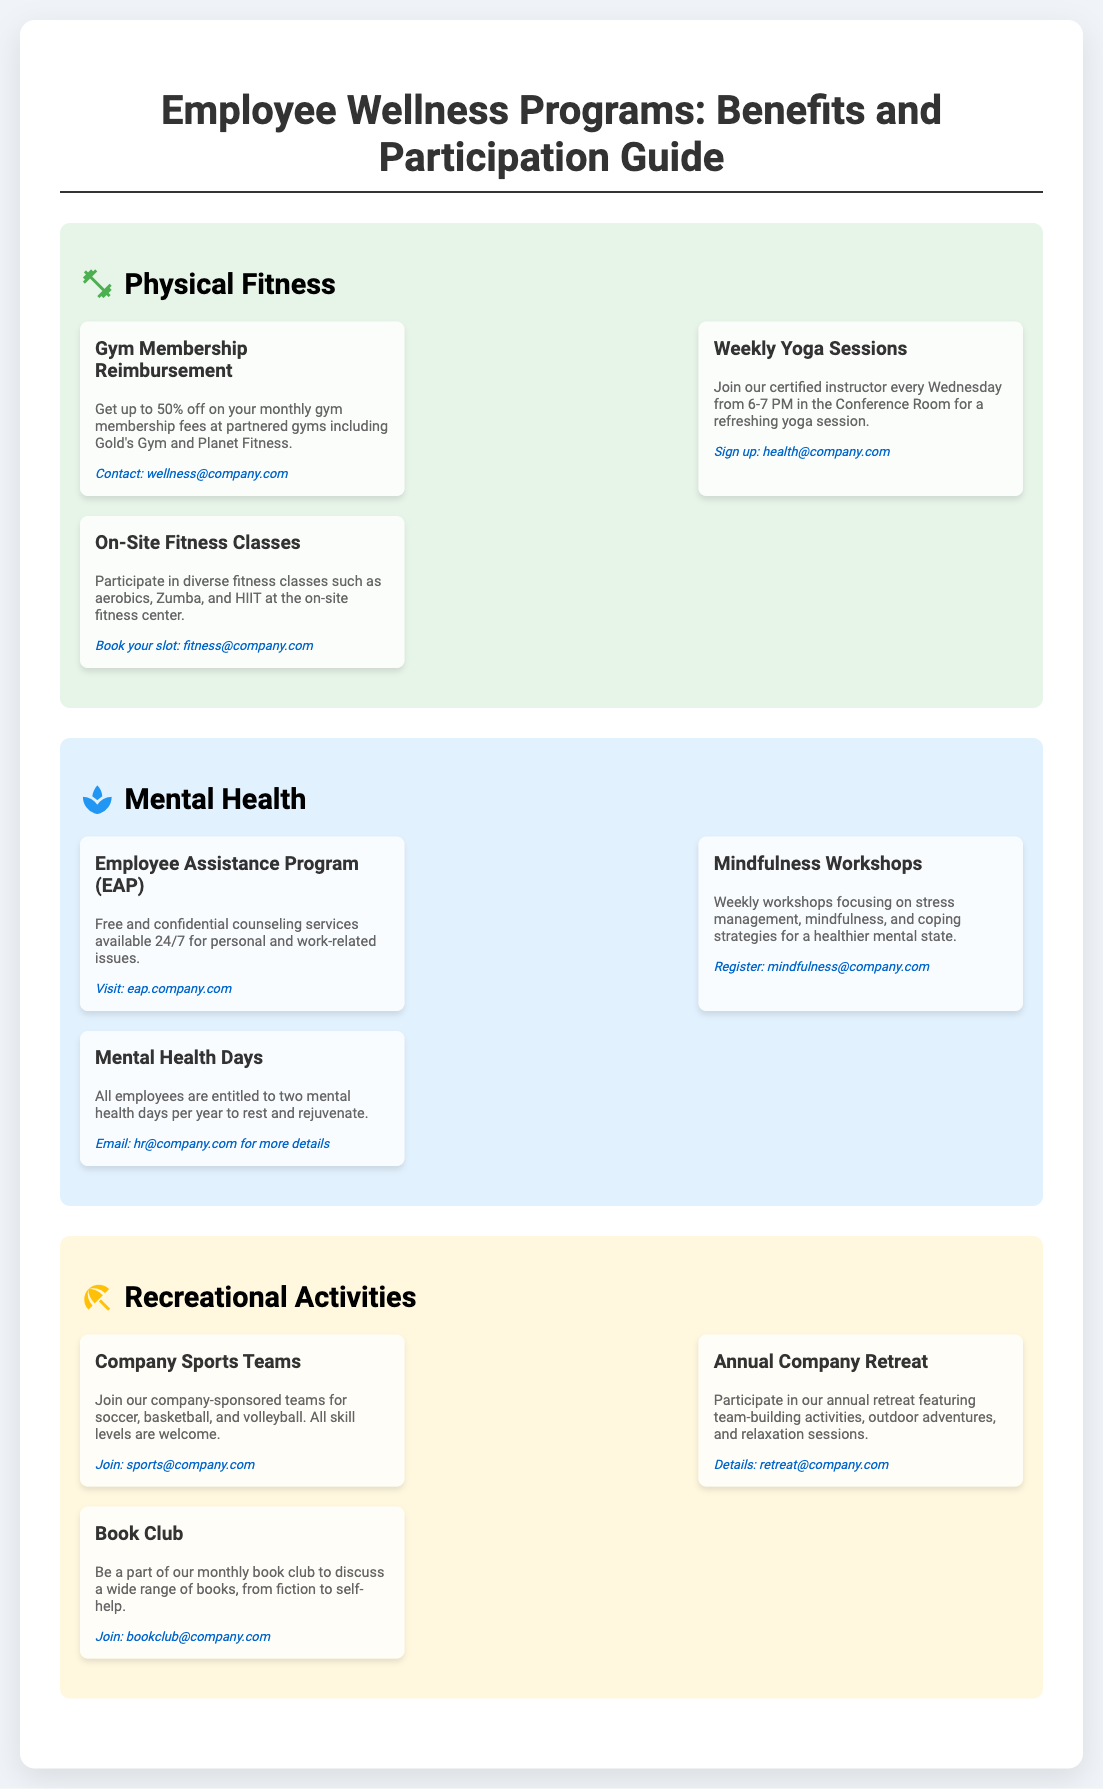What is the title of the poster? The title of the poster is prominently displayed at the top, outlining the focus on employee wellness programs.
Answer: Employee Wellness Programs: Benefits and Participation Guide How many mental health days are employees entitled to per year? The document specifically states the number of mental health days entitled to employees.
Answer: Two What is the contact email for gym membership reimbursement? The contact email related to gym membership reimbursement is provided in the details section of the program.
Answer: wellness@company.com When are the weekly yoga sessions held? The timing of the weekly yoga sessions is mentioned in the description for that activity.
Answer: Wednesdays from 6-7 PM What type of program offers free and confidential counseling services? The document categorizes services related to mental health under specific programs, including this particular program offering counseling.
Answer: Employee Assistance Program (EAP) Which recreational activity includes a monthly discussion? The description for this activity clearly states its purpose and frequency.
Answer: Book Club What kind of fitness classes are available on-site? The types of fitness classes available are specified in the details section of physical fitness.
Answer: Aerobics, Zumba, and HIIT What is the purpose of the annual company retreat? The purpose of the annual retreat aligns with team-building and other activities, as detailed in the recreational activities section.
Answer: Team-building activities, outdoor adventures, and relaxation sessions 